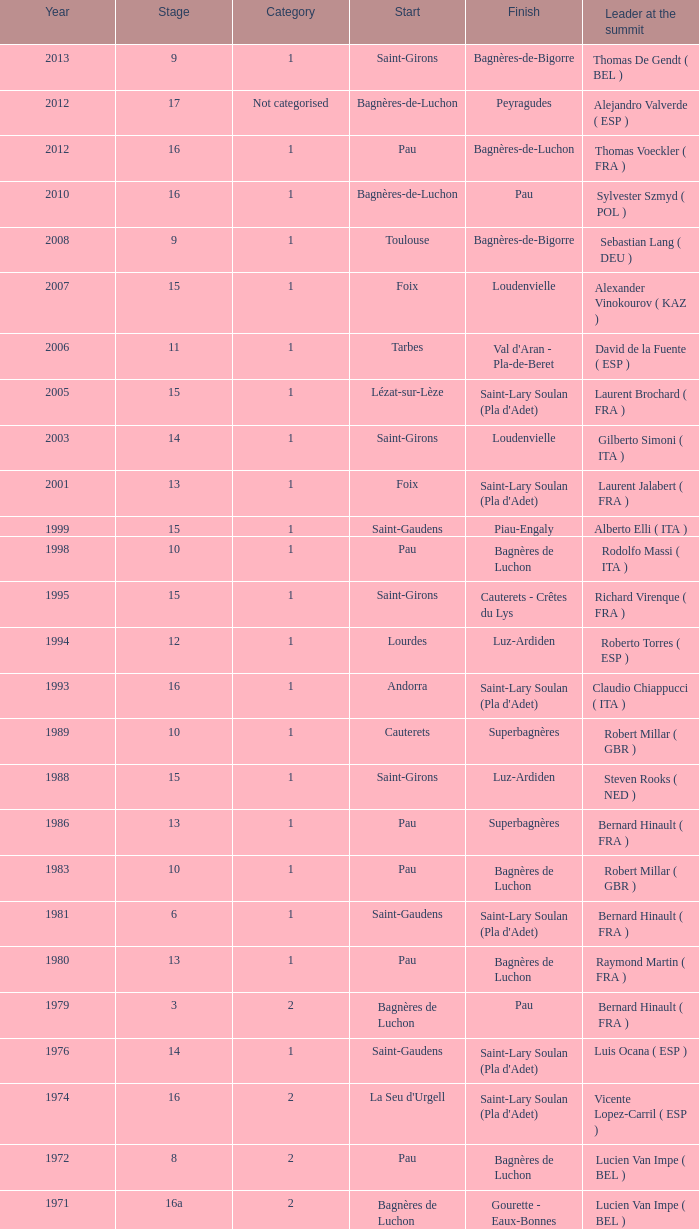What stage has a start of saint-girons in 1988? 15.0. Can you parse all the data within this table? {'header': ['Year', 'Stage', 'Category', 'Start', 'Finish', 'Leader at the summit'], 'rows': [['2013', '9', '1', 'Saint-Girons', 'Bagnères-de-Bigorre', 'Thomas De Gendt ( BEL )'], ['2012', '17', 'Not categorised', 'Bagnères-de-Luchon', 'Peyragudes', 'Alejandro Valverde ( ESP )'], ['2012', '16', '1', 'Pau', 'Bagnères-de-Luchon', 'Thomas Voeckler ( FRA )'], ['2010', '16', '1', 'Bagnères-de-Luchon', 'Pau', 'Sylvester Szmyd ( POL )'], ['2008', '9', '1', 'Toulouse', 'Bagnères-de-Bigorre', 'Sebastian Lang ( DEU )'], ['2007', '15', '1', 'Foix', 'Loudenvielle', 'Alexander Vinokourov ( KAZ )'], ['2006', '11', '1', 'Tarbes', "Val d'Aran - Pla-de-Beret", 'David de la Fuente ( ESP )'], ['2005', '15', '1', 'Lézat-sur-Lèze', "Saint-Lary Soulan (Pla d'Adet)", 'Laurent Brochard ( FRA )'], ['2003', '14', '1', 'Saint-Girons', 'Loudenvielle', 'Gilberto Simoni ( ITA )'], ['2001', '13', '1', 'Foix', "Saint-Lary Soulan (Pla d'Adet)", 'Laurent Jalabert ( FRA )'], ['1999', '15', '1', 'Saint-Gaudens', 'Piau-Engaly', 'Alberto Elli ( ITA )'], ['1998', '10', '1', 'Pau', 'Bagnères de Luchon', 'Rodolfo Massi ( ITA )'], ['1995', '15', '1', 'Saint-Girons', 'Cauterets - Crêtes du Lys', 'Richard Virenque ( FRA )'], ['1994', '12', '1', 'Lourdes', 'Luz-Ardiden', 'Roberto Torres ( ESP )'], ['1993', '16', '1', 'Andorra', "Saint-Lary Soulan (Pla d'Adet)", 'Claudio Chiappucci ( ITA )'], ['1989', '10', '1', 'Cauterets', 'Superbagnères', 'Robert Millar ( GBR )'], ['1988', '15', '1', 'Saint-Girons', 'Luz-Ardiden', 'Steven Rooks ( NED )'], ['1986', '13', '1', 'Pau', 'Superbagnères', 'Bernard Hinault ( FRA )'], ['1983', '10', '1', 'Pau', 'Bagnères de Luchon', 'Robert Millar ( GBR )'], ['1981', '6', '1', 'Saint-Gaudens', "Saint-Lary Soulan (Pla d'Adet)", 'Bernard Hinault ( FRA )'], ['1980', '13', '1', 'Pau', 'Bagnères de Luchon', 'Raymond Martin ( FRA )'], ['1979', '3', '2', 'Bagnères de Luchon', 'Pau', 'Bernard Hinault ( FRA )'], ['1976', '14', '1', 'Saint-Gaudens', "Saint-Lary Soulan (Pla d'Adet)", 'Luis Ocana ( ESP )'], ['1974', '16', '2', "La Seu d'Urgell", "Saint-Lary Soulan (Pla d'Adet)", 'Vicente Lopez-Carril ( ESP )'], ['1972', '8', '2', 'Pau', 'Bagnères de Luchon', 'Lucien Van Impe ( BEL )'], ['1971', '16a', '2', 'Bagnères de Luchon', 'Gourette - Eaux-Bonnes', 'Lucien Van Impe ( BEL )'], ['1970', '18', '2', 'Saint-Gaudens', 'La Mongie', 'Raymond Delisle ( FRA )'], ['1969', '17', '2', 'La Mongie', 'Mourenx', 'Joaquim Galera ( ESP )'], ['1964', '16', '2', 'Bagnères de Luchon', 'Pau', 'Julio Jiménez ( ESP )'], ['1963', '11', '2', 'Bagnères-de-Bigorre', 'Bagnères de Luchon', 'Federico Bahamontes ( ESP )'], ['1962', '12', '2', 'Pau', 'Saint-Gaudens', 'Federico Bahamontes ( ESP )'], ['1961', '17', '2', 'Bagnères de Luchon', 'Pau', 'Imerio Massignan ( ITA )'], ['1960', '11', '1', 'Pau', 'Bagnères de Luchon', 'Kurt Gimmi ( SUI )'], ['1959', '11', '1', 'Bagnères-de-Bigorre', 'Saint-Gaudens', 'Valentin Huot ( FRA )'], ['1958', '14', '1', 'Pau', 'Bagnères de Luchon', 'Federico Bahamontes ( ESP )'], ['1956', '12', 'Not categorised', 'Pau', 'Bagnères de Luchon', 'Jean-Pierre Schmitz ( LUX )'], ['1955', '17', '2', 'Toulouse', 'Saint-Gaudens', 'Charly Gaul ( LUX )'], ['1954', '12', '2', 'Pau', 'Bagnères de Luchon', 'Federico Bahamontes ( ESP )'], ['1953', '11', '2', 'Cauterets', 'Bagnères de Luchon', 'Jean Robic ( FRA )'], ['1952', '17', '2', 'Toulouse', 'Bagnères-de-Bigorre', 'Antonio Gelabert ( ESP )'], ['1951', '14', '2', 'Tarbes', 'Bagnères de Luchon', 'Fausto Coppi ( ITA )'], ['1949', '11', '2', 'Pau', 'Bagnères de Luchon', 'Jean Robic ( FRA )'], ['1948', '8', '2', 'Lourdes', 'Toulouse', 'Jean Robic ( FRA )'], ['1947', '15', '1', 'Bagnères de Luchon', 'Pau', 'Jean Robic ( FRA )']]} 